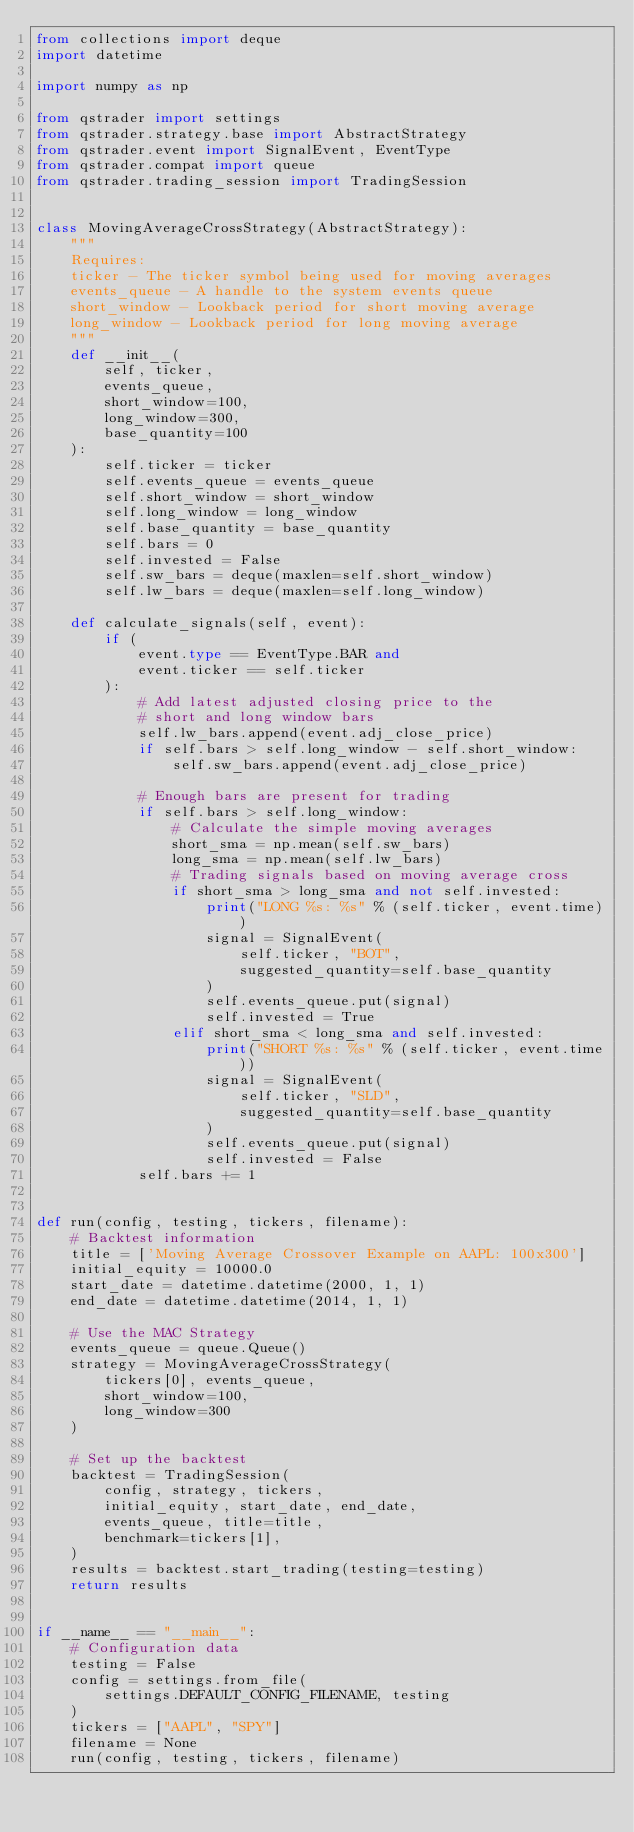<code> <loc_0><loc_0><loc_500><loc_500><_Python_>from collections import deque
import datetime

import numpy as np

from qstrader import settings
from qstrader.strategy.base import AbstractStrategy
from qstrader.event import SignalEvent, EventType
from qstrader.compat import queue
from qstrader.trading_session import TradingSession


class MovingAverageCrossStrategy(AbstractStrategy):
    """
    Requires:
    ticker - The ticker symbol being used for moving averages
    events_queue - A handle to the system events queue
    short_window - Lookback period for short moving average
    long_window - Lookback period for long moving average
    """
    def __init__(
        self, ticker,
        events_queue,
        short_window=100,
        long_window=300,
        base_quantity=100
    ):
        self.ticker = ticker
        self.events_queue = events_queue
        self.short_window = short_window
        self.long_window = long_window
        self.base_quantity = base_quantity
        self.bars = 0
        self.invested = False
        self.sw_bars = deque(maxlen=self.short_window)
        self.lw_bars = deque(maxlen=self.long_window)

    def calculate_signals(self, event):
        if (
            event.type == EventType.BAR and
            event.ticker == self.ticker
        ):
            # Add latest adjusted closing price to the
            # short and long window bars
            self.lw_bars.append(event.adj_close_price)
            if self.bars > self.long_window - self.short_window:
                self.sw_bars.append(event.adj_close_price)

            # Enough bars are present for trading
            if self.bars > self.long_window:
                # Calculate the simple moving averages
                short_sma = np.mean(self.sw_bars)
                long_sma = np.mean(self.lw_bars)
                # Trading signals based on moving average cross
                if short_sma > long_sma and not self.invested:
                    print("LONG %s: %s" % (self.ticker, event.time))
                    signal = SignalEvent(
                        self.ticker, "BOT",
                        suggested_quantity=self.base_quantity
                    )
                    self.events_queue.put(signal)
                    self.invested = True
                elif short_sma < long_sma and self.invested:
                    print("SHORT %s: %s" % (self.ticker, event.time))
                    signal = SignalEvent(
                        self.ticker, "SLD",
                        suggested_quantity=self.base_quantity
                    )
                    self.events_queue.put(signal)
                    self.invested = False
            self.bars += 1


def run(config, testing, tickers, filename):
    # Backtest information
    title = ['Moving Average Crossover Example on AAPL: 100x300']
    initial_equity = 10000.0
    start_date = datetime.datetime(2000, 1, 1)
    end_date = datetime.datetime(2014, 1, 1)

    # Use the MAC Strategy
    events_queue = queue.Queue()
    strategy = MovingAverageCrossStrategy(
        tickers[0], events_queue,
        short_window=100,
        long_window=300
    )

    # Set up the backtest
    backtest = TradingSession(
        config, strategy, tickers,
        initial_equity, start_date, end_date,
        events_queue, title=title,
        benchmark=tickers[1],
    )
    results = backtest.start_trading(testing=testing)
    return results


if __name__ == "__main__":
    # Configuration data
    testing = False
    config = settings.from_file(
        settings.DEFAULT_CONFIG_FILENAME, testing
    )
    tickers = ["AAPL", "SPY"]
    filename = None
    run(config, testing, tickers, filename)
</code> 